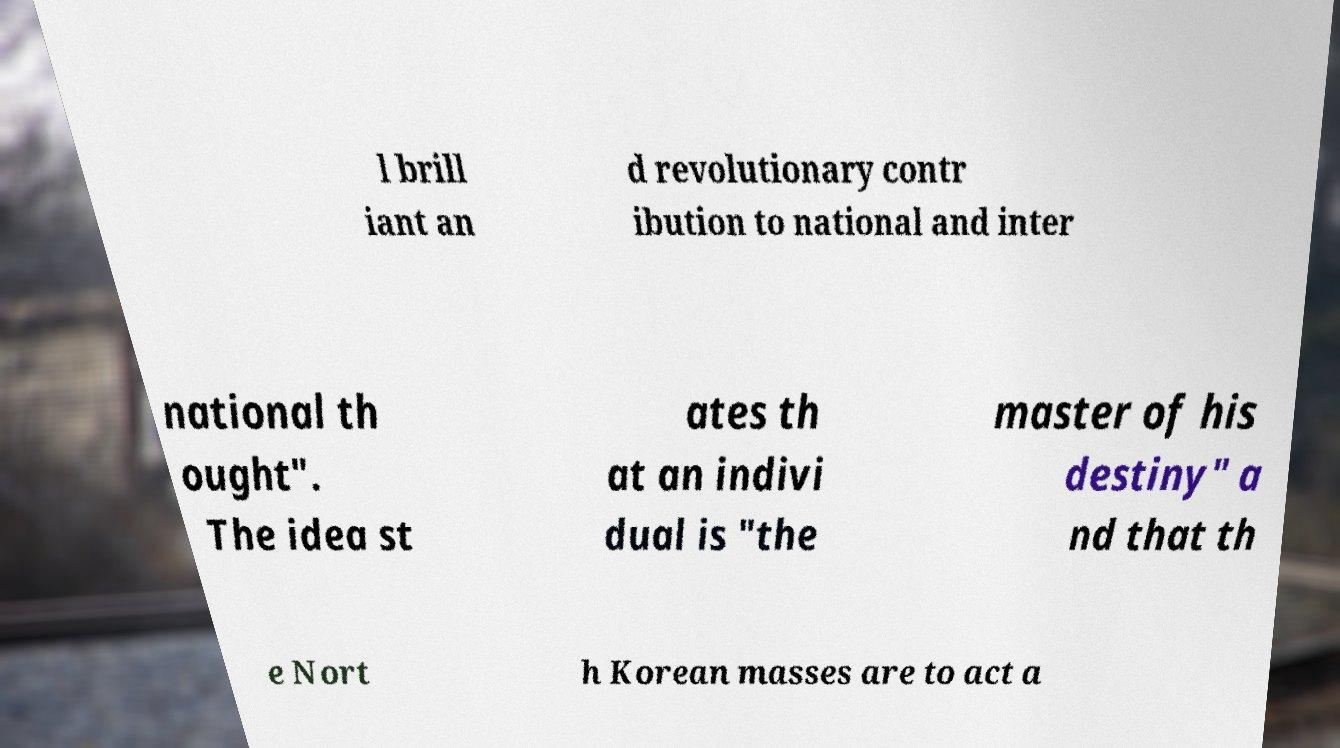Can you read and provide the text displayed in the image?This photo seems to have some interesting text. Can you extract and type it out for me? l brill iant an d revolutionary contr ibution to national and inter national th ought". The idea st ates th at an indivi dual is "the master of his destiny" a nd that th e Nort h Korean masses are to act a 